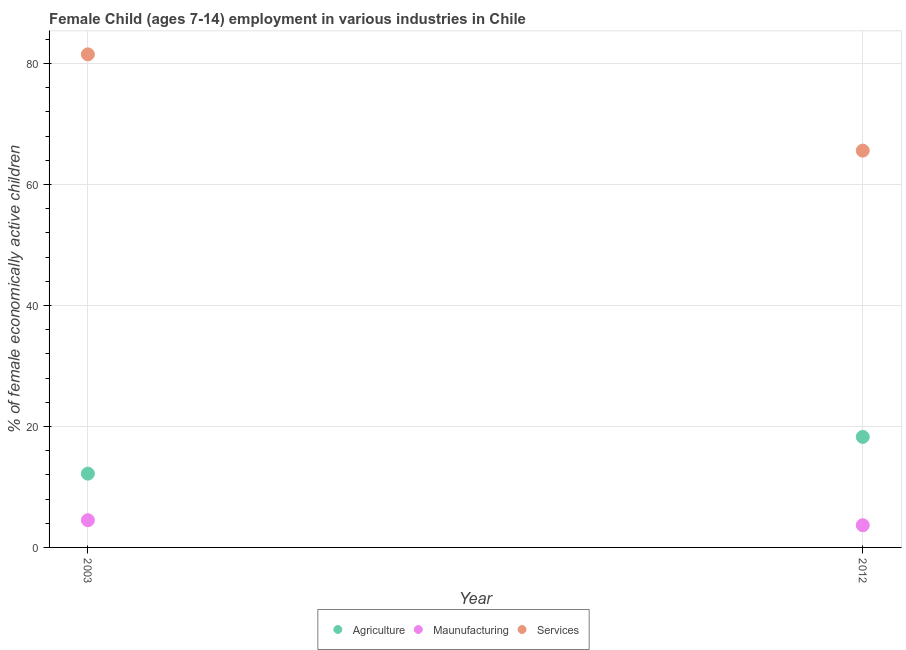How many different coloured dotlines are there?
Keep it short and to the point. 3. Is the number of dotlines equal to the number of legend labels?
Keep it short and to the point. Yes. What is the percentage of economically active children in services in 2003?
Provide a short and direct response. 81.5. Across all years, what is the minimum percentage of economically active children in manufacturing?
Offer a terse response. 3.67. What is the total percentage of economically active children in agriculture in the graph?
Give a very brief answer. 30.47. What is the difference between the percentage of economically active children in services in 2003 and that in 2012?
Ensure brevity in your answer.  15.91. What is the difference between the percentage of economically active children in manufacturing in 2003 and the percentage of economically active children in services in 2012?
Offer a very short reply. -61.09. What is the average percentage of economically active children in manufacturing per year?
Your response must be concise. 4.08. In the year 2012, what is the difference between the percentage of economically active children in manufacturing and percentage of economically active children in services?
Your answer should be compact. -61.92. In how many years, is the percentage of economically active children in services greater than 16 %?
Give a very brief answer. 2. What is the ratio of the percentage of economically active children in manufacturing in 2003 to that in 2012?
Your answer should be compact. 1.23. In how many years, is the percentage of economically active children in agriculture greater than the average percentage of economically active children in agriculture taken over all years?
Your answer should be very brief. 1. Does the percentage of economically active children in agriculture monotonically increase over the years?
Offer a very short reply. Yes. Is the percentage of economically active children in manufacturing strictly less than the percentage of economically active children in services over the years?
Offer a very short reply. Yes. What is the difference between two consecutive major ticks on the Y-axis?
Keep it short and to the point. 20. Does the graph contain any zero values?
Offer a terse response. No. Where does the legend appear in the graph?
Ensure brevity in your answer.  Bottom center. What is the title of the graph?
Ensure brevity in your answer.  Female Child (ages 7-14) employment in various industries in Chile. Does "Slovak Republic" appear as one of the legend labels in the graph?
Ensure brevity in your answer.  No. What is the label or title of the X-axis?
Provide a succinct answer. Year. What is the label or title of the Y-axis?
Provide a short and direct response. % of female economically active children. What is the % of female economically active children of Agriculture in 2003?
Offer a very short reply. 12.2. What is the % of female economically active children of Maunufacturing in 2003?
Keep it short and to the point. 4.5. What is the % of female economically active children of Services in 2003?
Your response must be concise. 81.5. What is the % of female economically active children of Agriculture in 2012?
Keep it short and to the point. 18.27. What is the % of female economically active children of Maunufacturing in 2012?
Provide a short and direct response. 3.67. What is the % of female economically active children in Services in 2012?
Offer a very short reply. 65.59. Across all years, what is the maximum % of female economically active children in Agriculture?
Provide a short and direct response. 18.27. Across all years, what is the maximum % of female economically active children in Maunufacturing?
Ensure brevity in your answer.  4.5. Across all years, what is the maximum % of female economically active children of Services?
Offer a terse response. 81.5. Across all years, what is the minimum % of female economically active children of Agriculture?
Ensure brevity in your answer.  12.2. Across all years, what is the minimum % of female economically active children of Maunufacturing?
Your answer should be compact. 3.67. Across all years, what is the minimum % of female economically active children in Services?
Make the answer very short. 65.59. What is the total % of female economically active children of Agriculture in the graph?
Offer a terse response. 30.47. What is the total % of female economically active children of Maunufacturing in the graph?
Provide a succinct answer. 8.17. What is the total % of female economically active children in Services in the graph?
Give a very brief answer. 147.09. What is the difference between the % of female economically active children in Agriculture in 2003 and that in 2012?
Give a very brief answer. -6.07. What is the difference between the % of female economically active children of Maunufacturing in 2003 and that in 2012?
Your answer should be compact. 0.83. What is the difference between the % of female economically active children in Services in 2003 and that in 2012?
Offer a terse response. 15.91. What is the difference between the % of female economically active children in Agriculture in 2003 and the % of female economically active children in Maunufacturing in 2012?
Your answer should be very brief. 8.53. What is the difference between the % of female economically active children of Agriculture in 2003 and the % of female economically active children of Services in 2012?
Your answer should be compact. -53.39. What is the difference between the % of female economically active children in Maunufacturing in 2003 and the % of female economically active children in Services in 2012?
Keep it short and to the point. -61.09. What is the average % of female economically active children in Agriculture per year?
Provide a succinct answer. 15.23. What is the average % of female economically active children in Maunufacturing per year?
Your response must be concise. 4.08. What is the average % of female economically active children in Services per year?
Your answer should be very brief. 73.55. In the year 2003, what is the difference between the % of female economically active children in Agriculture and % of female economically active children in Services?
Provide a short and direct response. -69.3. In the year 2003, what is the difference between the % of female economically active children of Maunufacturing and % of female economically active children of Services?
Make the answer very short. -77. In the year 2012, what is the difference between the % of female economically active children of Agriculture and % of female economically active children of Maunufacturing?
Keep it short and to the point. 14.6. In the year 2012, what is the difference between the % of female economically active children in Agriculture and % of female economically active children in Services?
Provide a short and direct response. -47.32. In the year 2012, what is the difference between the % of female economically active children in Maunufacturing and % of female economically active children in Services?
Offer a very short reply. -61.92. What is the ratio of the % of female economically active children of Agriculture in 2003 to that in 2012?
Give a very brief answer. 0.67. What is the ratio of the % of female economically active children in Maunufacturing in 2003 to that in 2012?
Give a very brief answer. 1.23. What is the ratio of the % of female economically active children in Services in 2003 to that in 2012?
Keep it short and to the point. 1.24. What is the difference between the highest and the second highest % of female economically active children in Agriculture?
Offer a very short reply. 6.07. What is the difference between the highest and the second highest % of female economically active children in Maunufacturing?
Provide a short and direct response. 0.83. What is the difference between the highest and the second highest % of female economically active children of Services?
Your answer should be compact. 15.91. What is the difference between the highest and the lowest % of female economically active children of Agriculture?
Your response must be concise. 6.07. What is the difference between the highest and the lowest % of female economically active children in Maunufacturing?
Ensure brevity in your answer.  0.83. What is the difference between the highest and the lowest % of female economically active children of Services?
Ensure brevity in your answer.  15.91. 